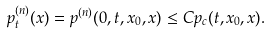Convert formula to latex. <formula><loc_0><loc_0><loc_500><loc_500>p _ { t } ^ { ( n ) } ( x ) = p ^ { ( n ) } ( 0 , t , x _ { 0 } , x ) \leq C p _ { c } ( t , x _ { 0 } , x ) .</formula> 